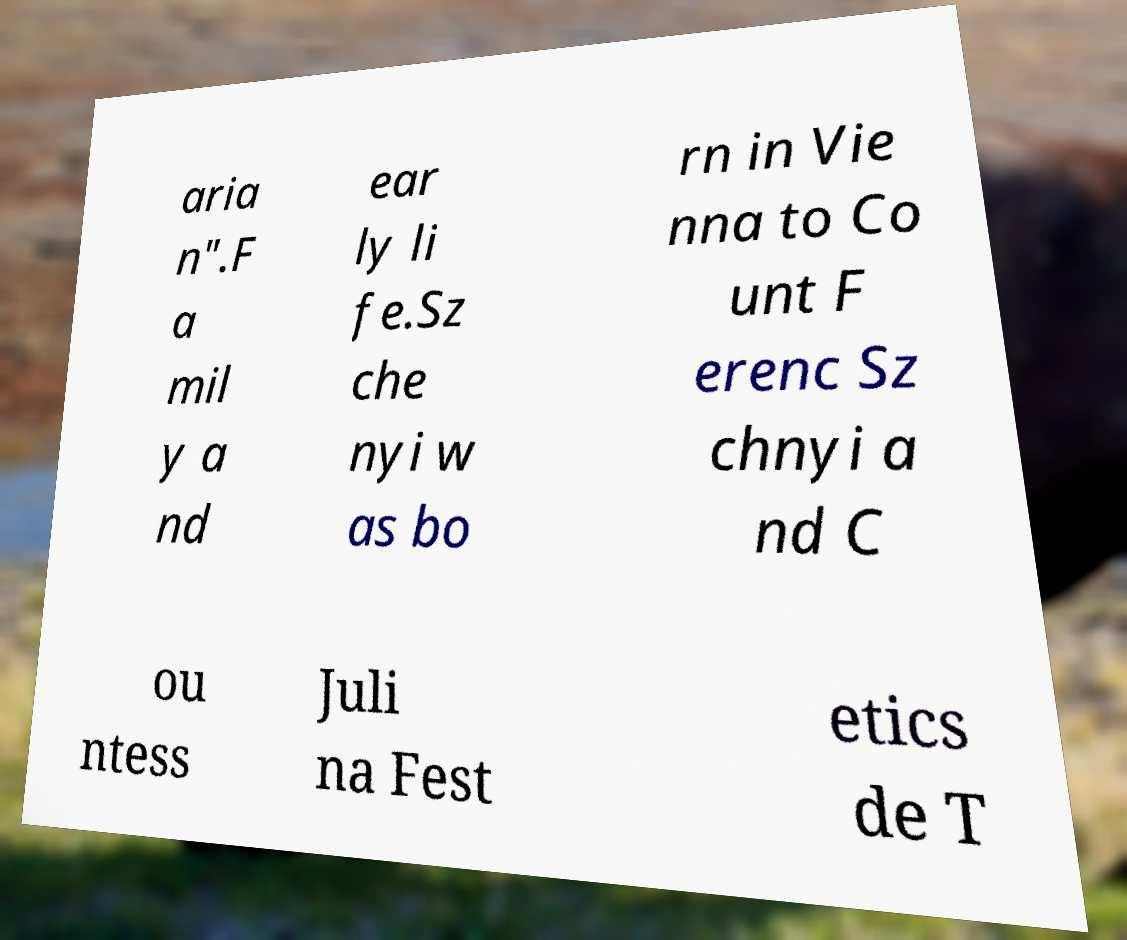What messages or text are displayed in this image? I need them in a readable, typed format. aria n".F a mil y a nd ear ly li fe.Sz che nyi w as bo rn in Vie nna to Co unt F erenc Sz chnyi a nd C ou ntess Juli na Fest etics de T 